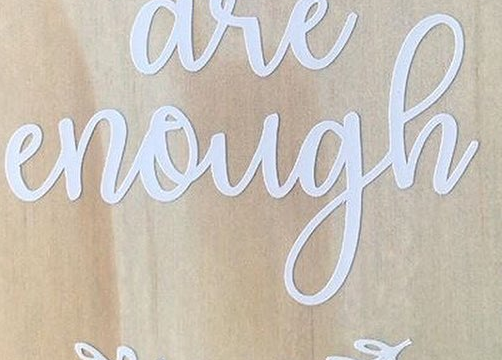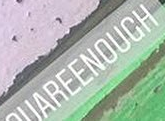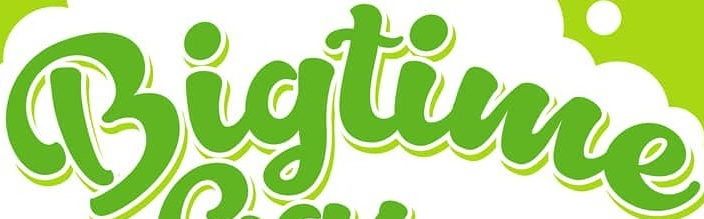What text appears in these images from left to right, separated by a semicolon? enough; UAREENOUCH; Bigtime 